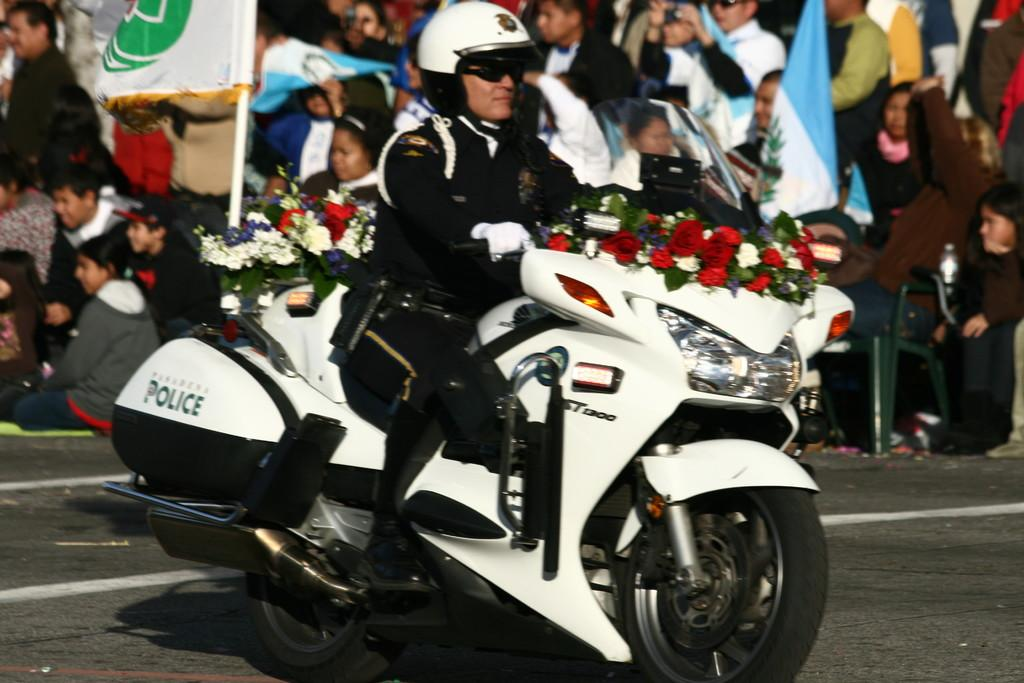Who is the main subject in the image? There is a man in the image. What is the man doing in the image? The man is riding a bike. What can be seen in the background of the image? There are many people and a flag in the background of the image. What type of tin can be seen in the image? There is no tin present in the image. How does the acoustics of the environment affect the man riding the bike in the image? The provided facts do not mention anything about the acoustics of the environment, so it cannot be determined how it affects the man riding the bike. 